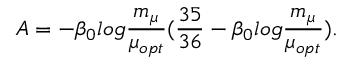<formula> <loc_0><loc_0><loc_500><loc_500>A = - \beta _ { 0 } \log \frac { m _ { \mu } } { \mu _ { o p t } } ( \frac { 3 5 } { 3 6 } - \beta _ { 0 } \log \frac { m _ { \mu } } { \mu _ { o p t } } ) .</formula> 